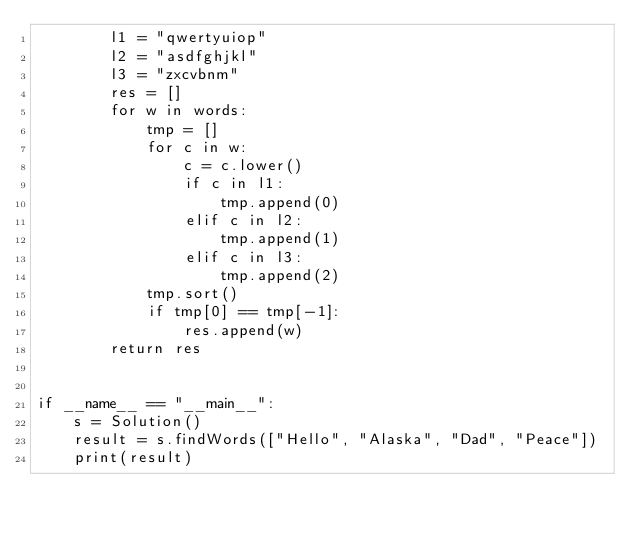Convert code to text. <code><loc_0><loc_0><loc_500><loc_500><_Python_>        l1 = "qwertyuiop"
        l2 = "asdfghjkl"
        l3 = "zxcvbnm"
        res = []
        for w in words:
            tmp = []
            for c in w:
                c = c.lower()
                if c in l1:
                    tmp.append(0)
                elif c in l2:
                    tmp.append(1)
                elif c in l3:
                    tmp.append(2)
            tmp.sort()
            if tmp[0] == tmp[-1]:
                res.append(w)
        return res


if __name__ == "__main__":
    s = Solution()
    result = s.findWords(["Hello", "Alaska", "Dad", "Peace"])
    print(result)
</code> 